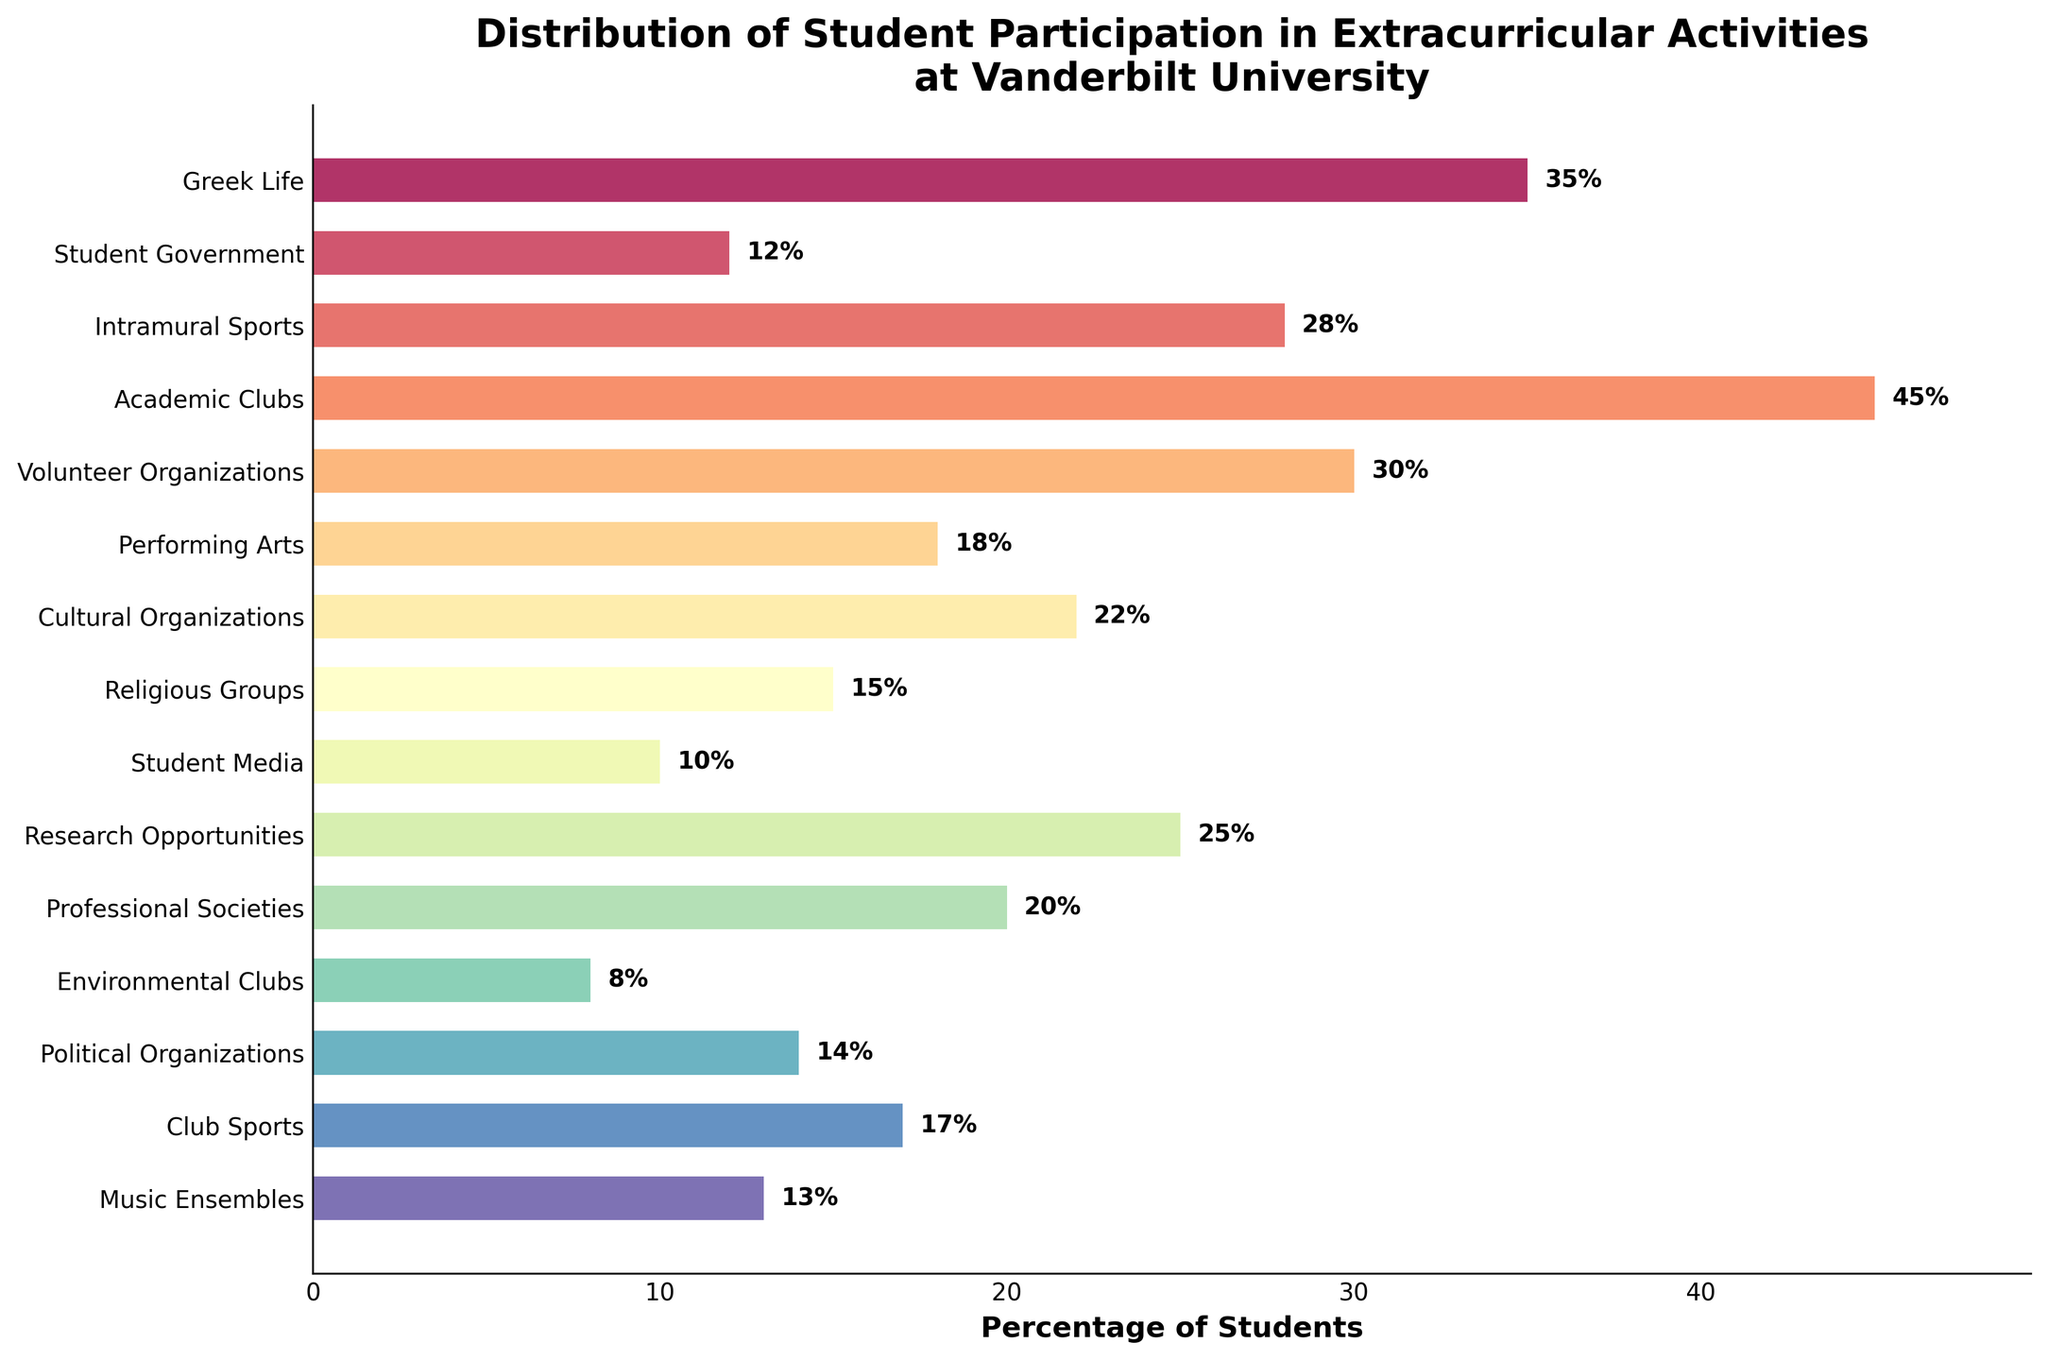What's the activity with the highest student participation percentage? Look at the bar with the greatest length. The label on the y-axis corresponding to this bar will indicate the activity with the highest student participation.
Answer: Academic Clubs How does the participation in Intramural Sports compare to Club Sports? Find the bars corresponding to Intramural Sports and Club Sports. Observe that the bar for Intramural Sports is longer than the bar for Club Sports, indicating a higher percentage of participation.
Answer: Intramural Sports has higher participation What is the total percentage of students participating in Greek Life and Student Government combined? Locate the bars for Greek Life and Student Government. Read their percentages (Greek Life: 35%, Student Government: 12%). Sum these percentages: 35% + 12% = 47%.
Answer: 47% How much greater is the participation in Volunteer Organizations compared to Environmental Clubs? Find the bars for Volunteer Organizations and Environmental Clubs. The percentages are 30% and 8% respectively. Subtract the smaller percentage from the larger one: 30% - 8% = 22%.
Answer: 22% Which activities have participation percentages between 10% and 20%? Identify the bars that have lengths corresponding to percentages between 10% and 20%. These activities are Performing Arts (18%), Cultural Organizations (22%), Religious Groups (15%), Student Media (10%), Political Organizations (14%), Club Sports (17%), Music Ensembles (13%).
Answer: Performing Arts, Cultural Organizations, Religious Groups, Student Media, Political Organizations, Club Sports, Music Ensembles Which activity has the least student participation, and what is its percentage? Look for the shortest bar in the chart. The label on the y-axis corresponding to this bar will indicate the activity with the lowest student participation. Read its percentage.
Answer: Environmental Clubs, 8% What is the average participation percentage across all extracurricular activities displayed? Add up all the percentages from each activity and divide by the total number of activities: (35 + 12 + 28 + 45 + 30 + 18 + 22 + 15 + 10 + 25 + 20 + 8 + 14 + 17 + 13) / 15. This equals 312 / 15 = 20.8%.
Answer: 20.8% What is the difference in participation percentage between Research Opportunities and Student Media? Locate the bars for Research Opportunities and Student Media. Their percentages are 25% and 10% respectively. Subtract the smaller percentage from the larger one: 25% - 10% = 15%.
Answer: 15% How many activities have a participation percentage greater than 20%? Identify and count the bars with lengths corresponding to percentages greater than 20%. These are: Greek Life (35%), Intramural Sports (28%), Academic Clubs (45%), Volunteer Organizations (30%), Cultural Organizations (22%), Research Opportunities (25%). Count these activities to get a total of 6.
Answer: 6 Which activity has similar participation to Political Organizations? Identify the bar corresponding to Political Organizations (14%) and, closely assess its length in comparison to other bars. The Religious Groups’ bar is visually similar, indicating it has a similar participation percentage (15%).
Answer: Religious Groups 